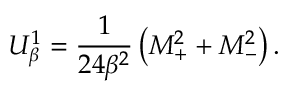Convert formula to latex. <formula><loc_0><loc_0><loc_500><loc_500>U _ { \beta } ^ { 1 } = \frac { 1 } { 2 4 \beta ^ { 2 } } \left ( M _ { + } ^ { 2 } + M _ { - } ^ { 2 } \right ) .</formula> 